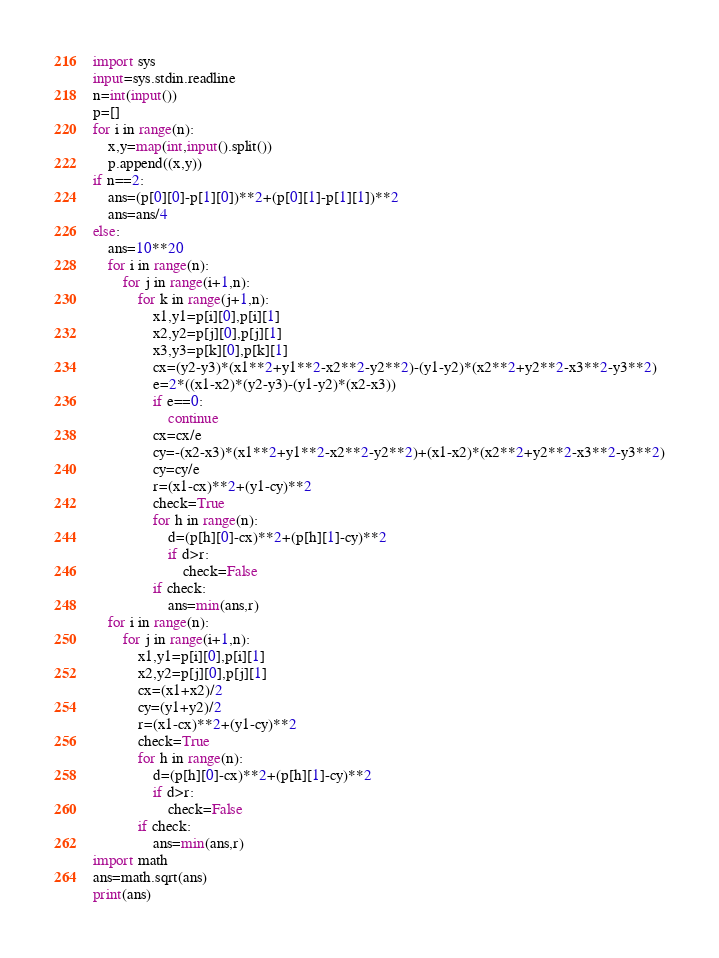Convert code to text. <code><loc_0><loc_0><loc_500><loc_500><_Python_>import sys
input=sys.stdin.readline
n=int(input())
p=[]
for i in range(n):
    x,y=map(int,input().split())
    p.append((x,y))
if n==2:
    ans=(p[0][0]-p[1][0])**2+(p[0][1]-p[1][1])**2
    ans=ans/4
else:
    ans=10**20
    for i in range(n):
        for j in range(i+1,n):
            for k in range(j+1,n):
                x1,y1=p[i][0],p[i][1]
                x2,y2=p[j][0],p[j][1]
                x3,y3=p[k][0],p[k][1]
                cx=(y2-y3)*(x1**2+y1**2-x2**2-y2**2)-(y1-y2)*(x2**2+y2**2-x3**2-y3**2)
                e=2*((x1-x2)*(y2-y3)-(y1-y2)*(x2-x3))
                if e==0:
                    continue
                cx=cx/e
                cy=-(x2-x3)*(x1**2+y1**2-x2**2-y2**2)+(x1-x2)*(x2**2+y2**2-x3**2-y3**2)
                cy=cy/e
                r=(x1-cx)**2+(y1-cy)**2
                check=True
                for h in range(n):
                    d=(p[h][0]-cx)**2+(p[h][1]-cy)**2
                    if d>r:
                        check=False
                if check:
                    ans=min(ans,r)
    for i in range(n):
        for j in range(i+1,n):
            x1,y1=p[i][0],p[i][1]
            x2,y2=p[j][0],p[j][1]
            cx=(x1+x2)/2
            cy=(y1+y2)/2
            r=(x1-cx)**2+(y1-cy)**2
            check=True
            for h in range(n):
                d=(p[h][0]-cx)**2+(p[h][1]-cy)**2
                if d>r:
                    check=False
            if check:
                ans=min(ans,r)
import math
ans=math.sqrt(ans)
print(ans)
</code> 